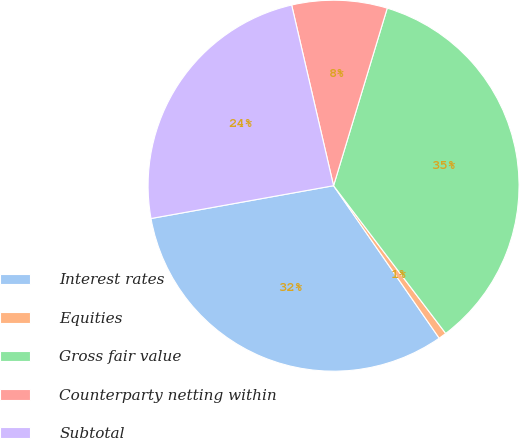<chart> <loc_0><loc_0><loc_500><loc_500><pie_chart><fcel>Interest rates<fcel>Equities<fcel>Gross fair value<fcel>Counterparty netting within<fcel>Subtotal<nl><fcel>31.81%<fcel>0.69%<fcel>34.99%<fcel>8.3%<fcel>24.2%<nl></chart> 